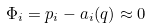<formula> <loc_0><loc_0><loc_500><loc_500>\Phi _ { i } = p _ { i } - a _ { i } ( q ) \approx 0</formula> 